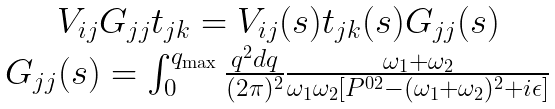<formula> <loc_0><loc_0><loc_500><loc_500>\begin{array} { c } V _ { i j } G _ { j j } t _ { j k } = V _ { i j } ( s ) t _ { j k } ( s ) G _ { j j } ( s ) \\ G _ { j j } ( s ) = \int _ { 0 } ^ { q _ { \max } } \frac { q ^ { 2 } d q } { ( 2 \pi ) ^ { 2 } } \frac { \omega _ { 1 } + \omega _ { 2 } } { \omega _ { 1 } \omega _ { 2 } [ P ^ { 0 2 } - ( \omega _ { 1 } + \omega _ { 2 } ) ^ { 2 } + i \epsilon ] } \end{array}</formula> 